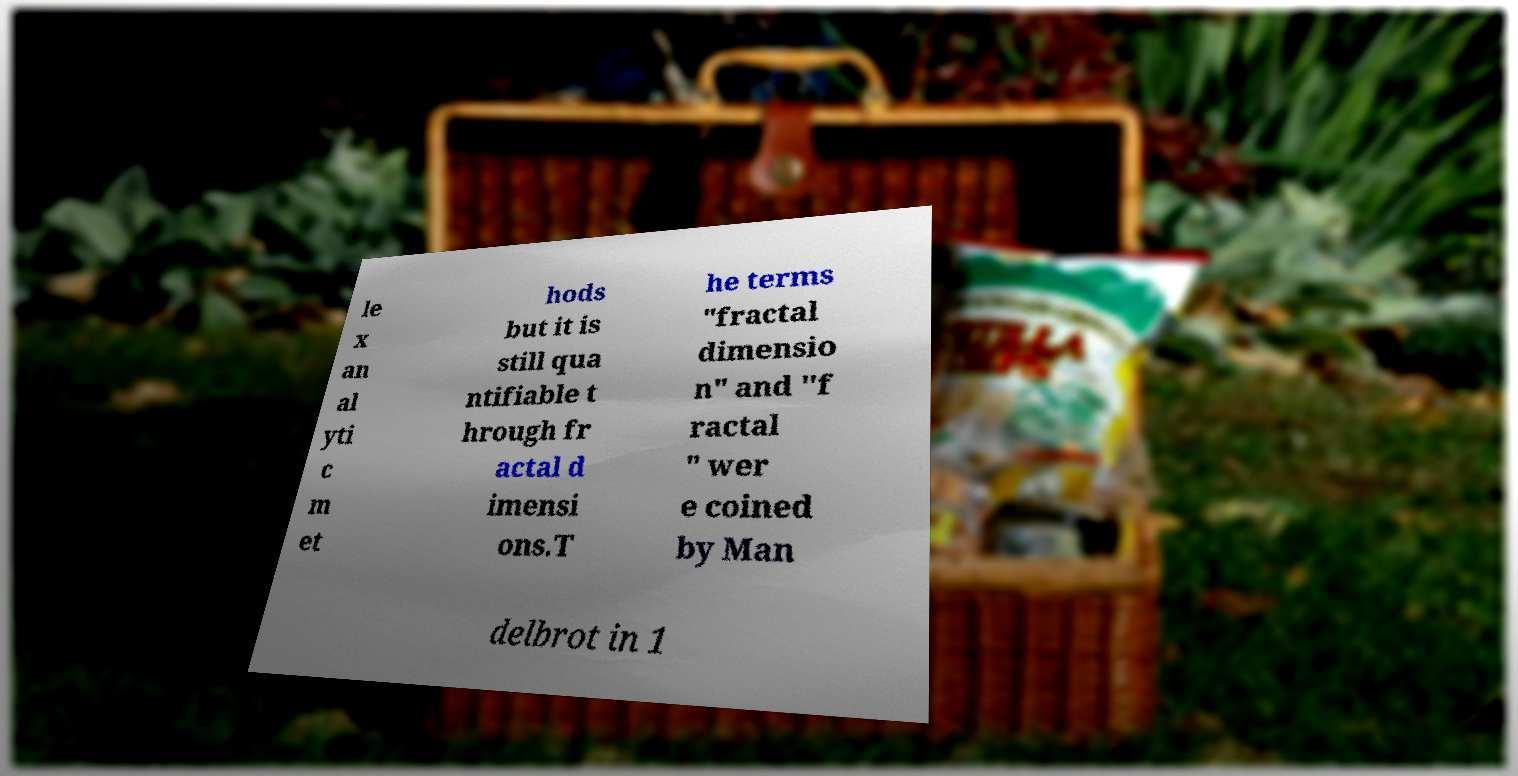Can you accurately transcribe the text from the provided image for me? le x an al yti c m et hods but it is still qua ntifiable t hrough fr actal d imensi ons.T he terms "fractal dimensio n" and "f ractal " wer e coined by Man delbrot in 1 